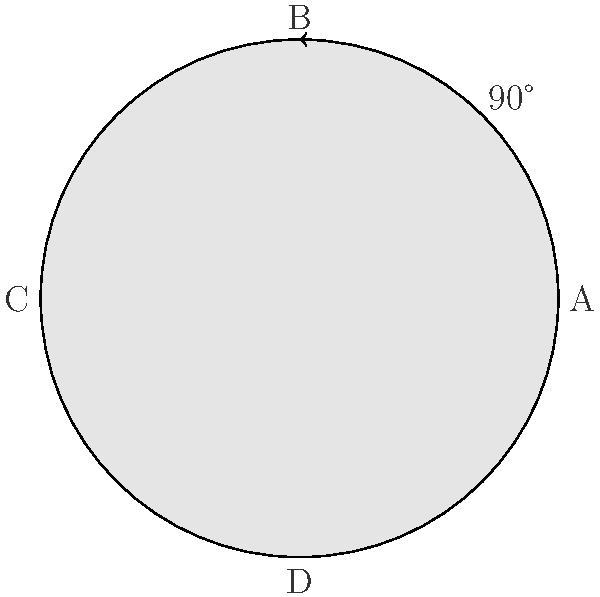A pill bottle has a child-resistant cap that requires a 90-degree rotation to open. If we consider the rotations of this cap as elements of a cyclic group, what is the order of the group generated by a single 90-degree rotation? To determine the order of the cyclic group generated by a 90-degree rotation of the pill bottle cap, we need to follow these steps:

1. Identify the generator: The generator of the group is a 90-degree rotation.

2. Apply the generator repeatedly:
   - Start position: A (0 degrees)
   - After 1 rotation: B (90 degrees)
   - After 2 rotations: C (180 degrees)
   - After 3 rotations: D (270 degrees)
   - After 4 rotations: A (360 degrees or 0 degrees)

3. Count the number of unique elements:
   We have 4 unique positions (A, B, C, D) before returning to the starting position.

4. Conclude: The group has 4 elements, corresponding to rotations of 0°, 90°, 180°, and 270°.

In group theory, the order of a cyclic group is the number of elements in the group. Here, we have 4 elements, so the order of the group is 4.

This can be represented mathematically as:
$$\langle r \rangle = \{e, r, r^2, r^3\}$$
where $r$ represents a 90-degree rotation, $e$ is the identity element (0-degree rotation), and the group operation is composition of rotations.
Answer: 4 